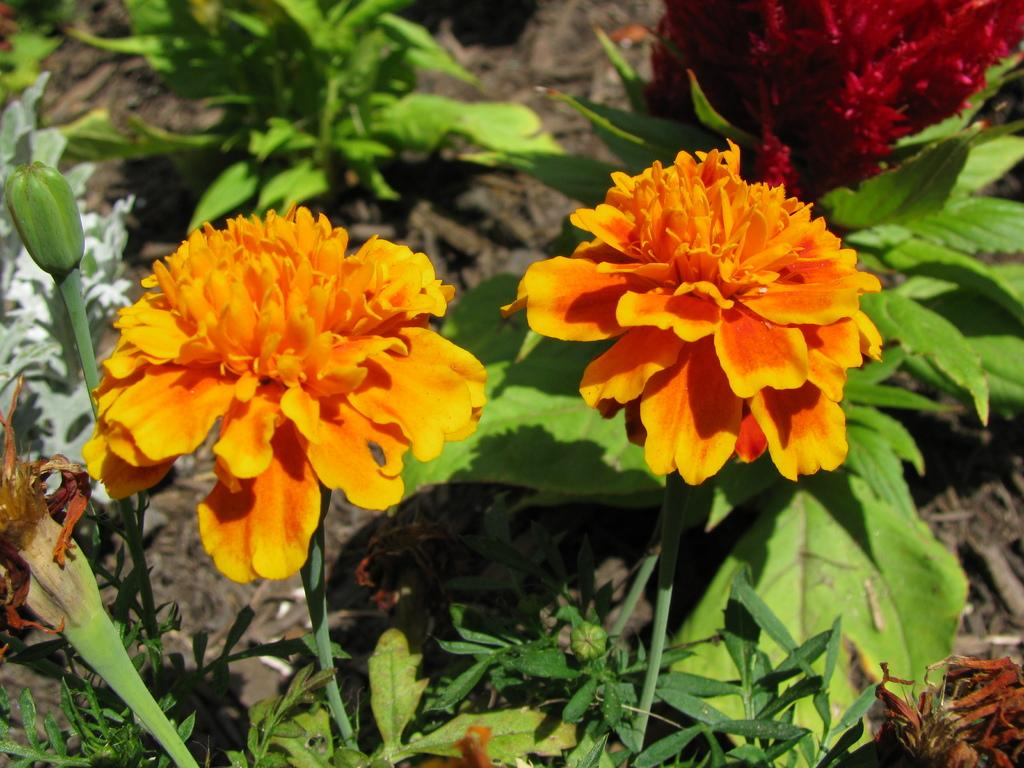What colors are the flowers on the plant in the image? The flowers on the plant are orange and red. What type of vegetation is at the bottom of the image? There is grass at the bottom of the image. What other parts of the plant can be seen in the image? There are leaves visible in the image. How many boats are parked near the plant in the image? There are no boats present in the image; it only features a plant with orange and red flowers, grass, and leaves. 